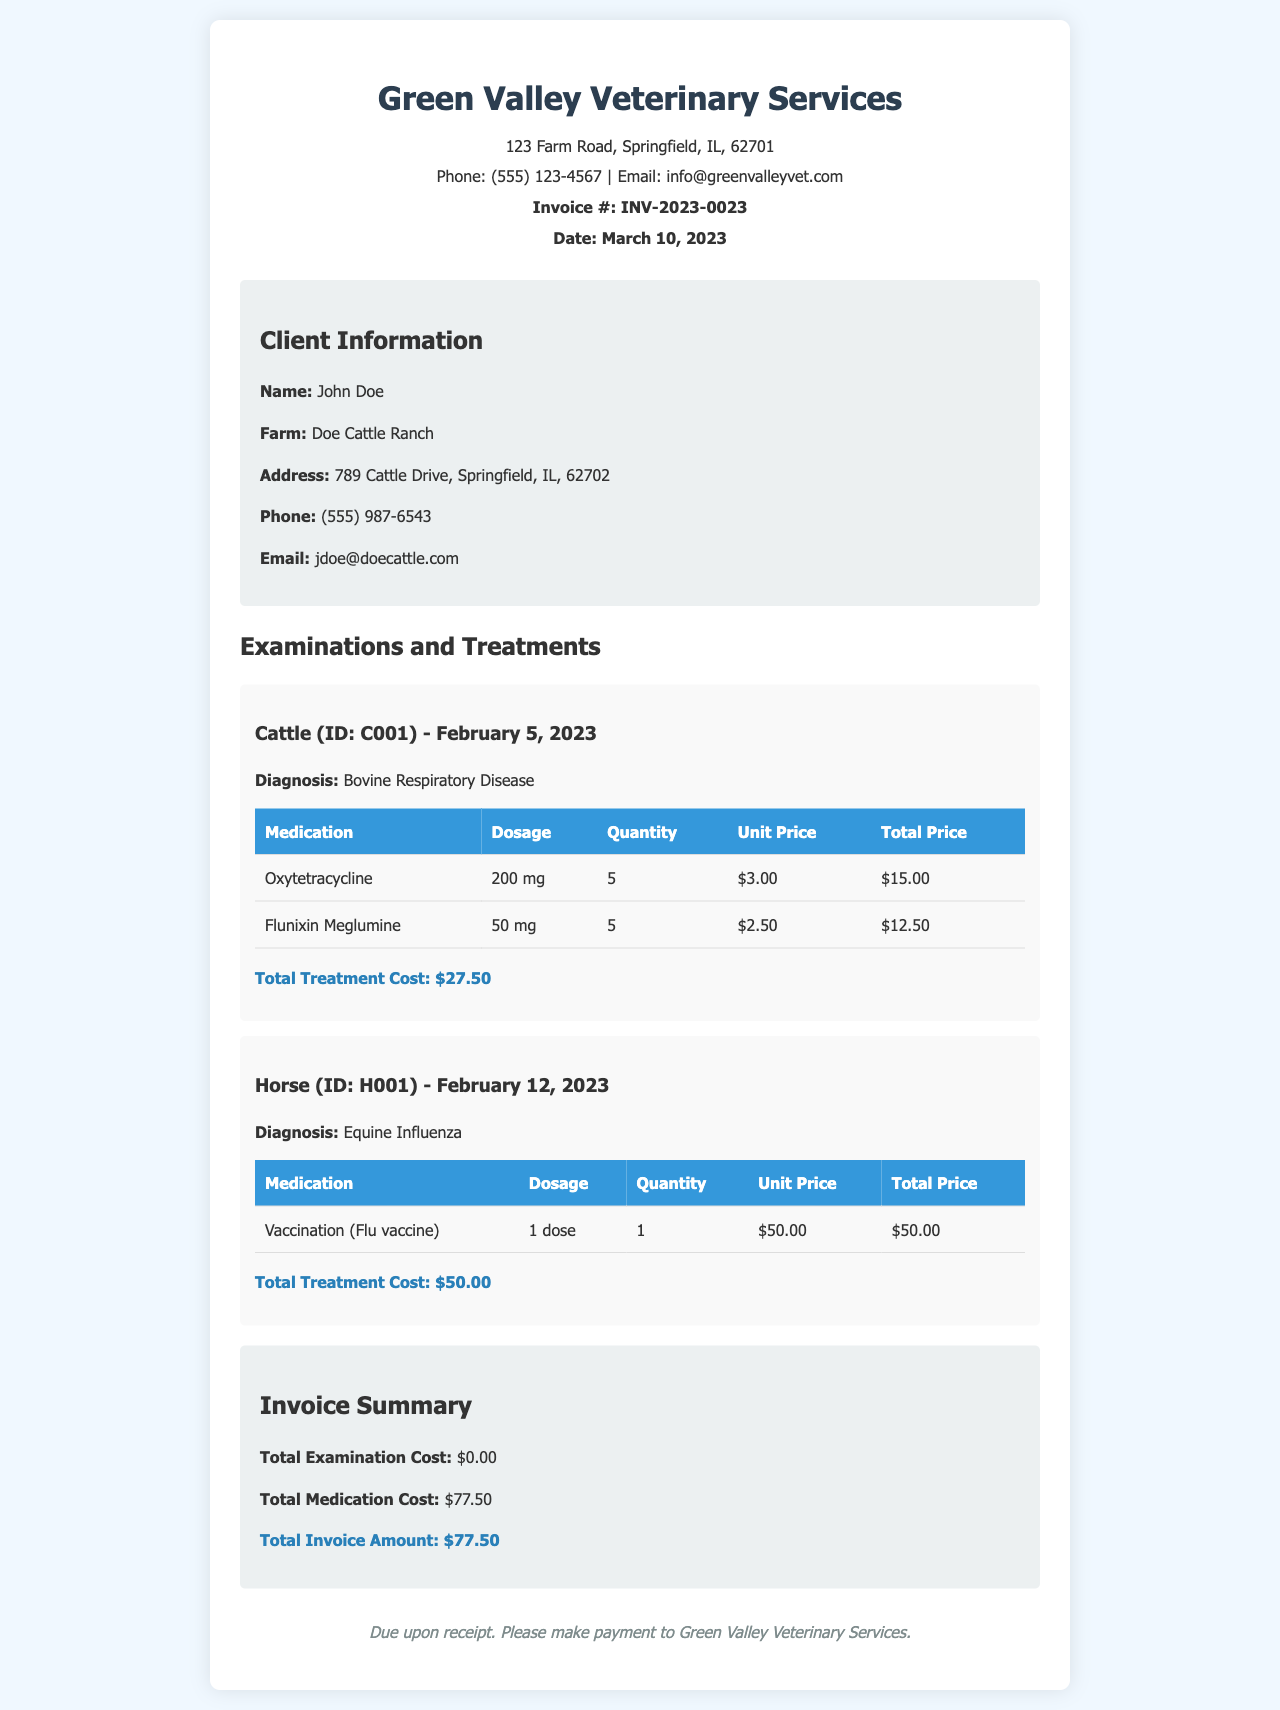What is the invoice number? The invoice number is listed prominently on the document under the title, which is INV-2023-0023.
Answer: INV-2023-0023 What is the total medication cost? The document provides a summary of costs at the bottom, showing the total medication cost is $77.50.
Answer: $77.50 What is the appointment date for the horse examination? The horse examination is dated February 12, 2023, as indicated in the examination section.
Answer: February 12, 2023 Who is the client for this invoice? The client's name is provided in the client details section, which states it is John Doe.
Answer: John Doe What is the diagnosis for the cattle? The diagnosis for the cattle is mentioned in the examination section, which states Bovine Respiratory Disease.
Answer: Bovine Respiratory Disease What is the unit price of Oxytetracycline? The unit price for Oxytetracycline is listed in the medication table for the cattle examination, which shows it as $3.00.
Answer: $3.00 How many doses of the flu vaccine were given to the horse? According to the medication table for the horse, only 1 dose of the flu vaccine was administered.
Answer: 1 dose What is the total treatment cost for cattle? The total treatment cost for cattle is shown at the end of the cattle examination section, which is $27.50.
Answer: $27.50 What is the total invoice amount? The total invoice amount is displayed in the summary section, which states it is $77.50.
Answer: $77.50 